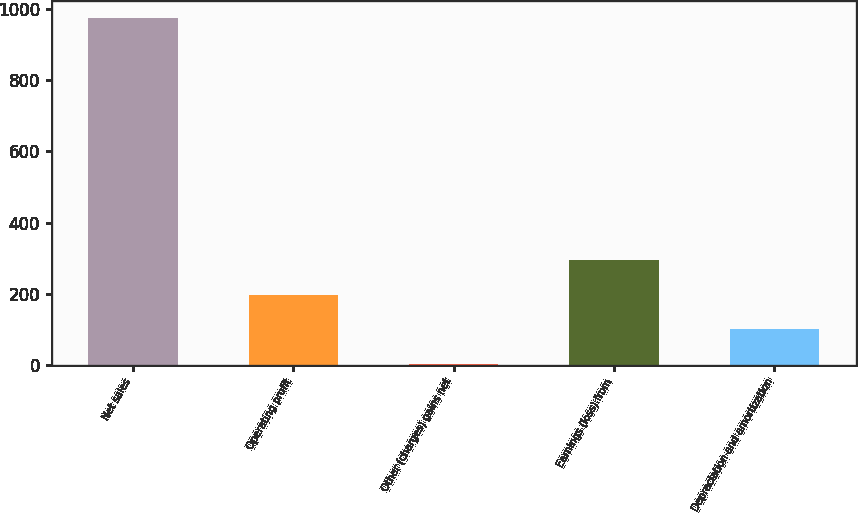Convert chart to OTSL. <chart><loc_0><loc_0><loc_500><loc_500><bar_chart><fcel>Net sales<fcel>Operating profit<fcel>Other (charges) gains net<fcel>Earnings (loss) from<fcel>Depreciation and amortization<nl><fcel>974<fcel>198<fcel>4<fcel>295<fcel>101<nl></chart> 